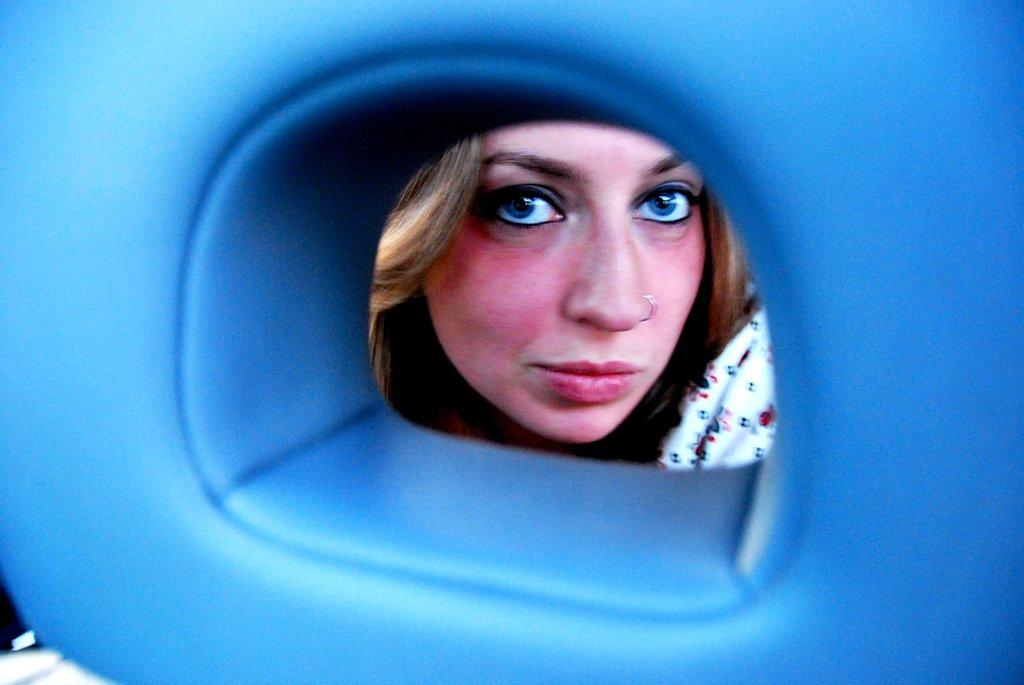What is the color of the substance in the image? The substance in the image is blue and colorless. What feature can be observed in the substance? There is a hole in the substance. What can be seen through the hole in the substance? A woman's face is visible through the hole. What type of test is being conducted on the woman's hands in the image? There is no test being conducted on the woman's hands in the image, nor are any hands visible. 